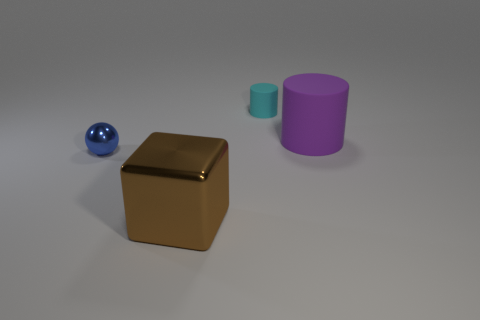What size is the cyan object?
Give a very brief answer. Small. The purple rubber object that is the same shape as the cyan matte object is what size?
Your answer should be very brief. Large. How many objects are to the left of the small cyan rubber cylinder?
Give a very brief answer. 2. There is a large thing that is in front of the purple matte cylinder behind the small metallic object; what color is it?
Make the answer very short. Brown. Is there anything else that is the same shape as the blue object?
Give a very brief answer. No. Are there an equal number of small matte things that are in front of the small shiny object and blue metallic balls behind the purple rubber cylinder?
Your answer should be very brief. Yes. What number of cylinders are either big brown rubber objects or large rubber objects?
Your response must be concise. 1. How many other objects are there of the same material as the blue sphere?
Give a very brief answer. 1. There is a small thing on the right side of the small blue metal thing; what shape is it?
Offer a terse response. Cylinder. What is the material of the cylinder that is in front of the tiny object that is on the right side of the ball?
Make the answer very short. Rubber. 